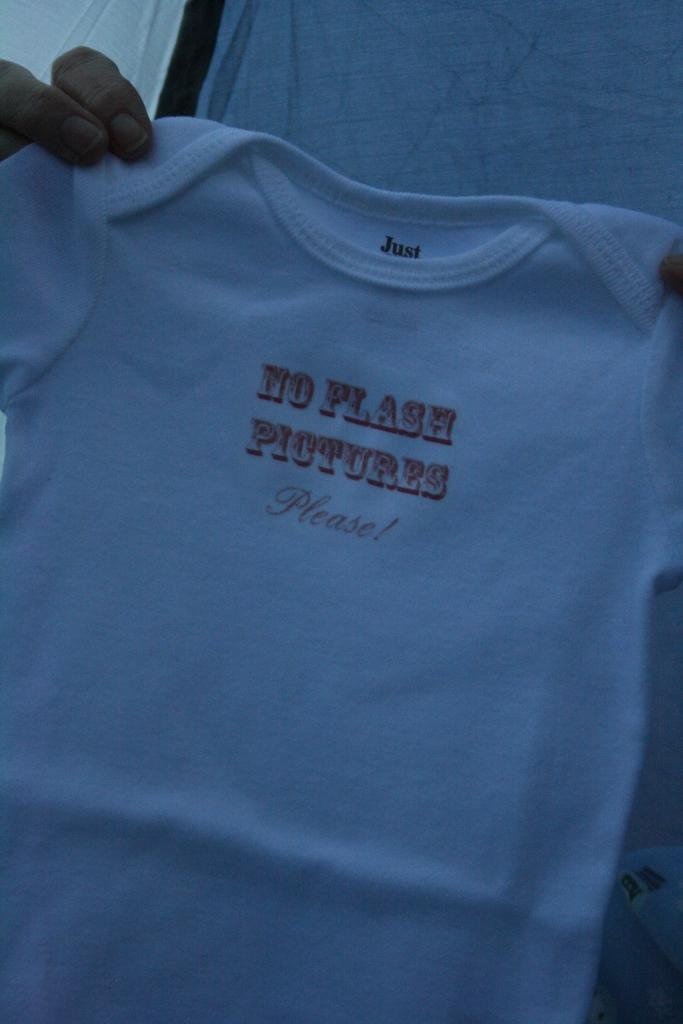<image>
Give a short and clear explanation of the subsequent image. A person is holding a shirt that says no pictures please. 